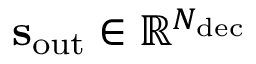<formula> <loc_0><loc_0><loc_500><loc_500>s _ { o u t } \in \mathbb { R } ^ { N _ { d e c } }</formula> 